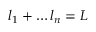Convert formula to latex. <formula><loc_0><loc_0><loc_500><loc_500>l _ { 1 } + \dots l _ { n } = L</formula> 